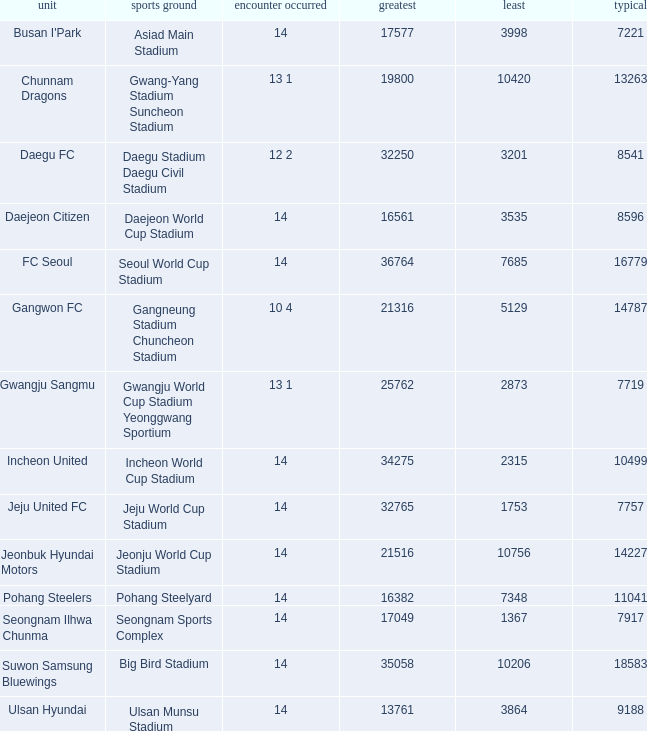What is the highest when pohang steelers is the team? 16382.0. 